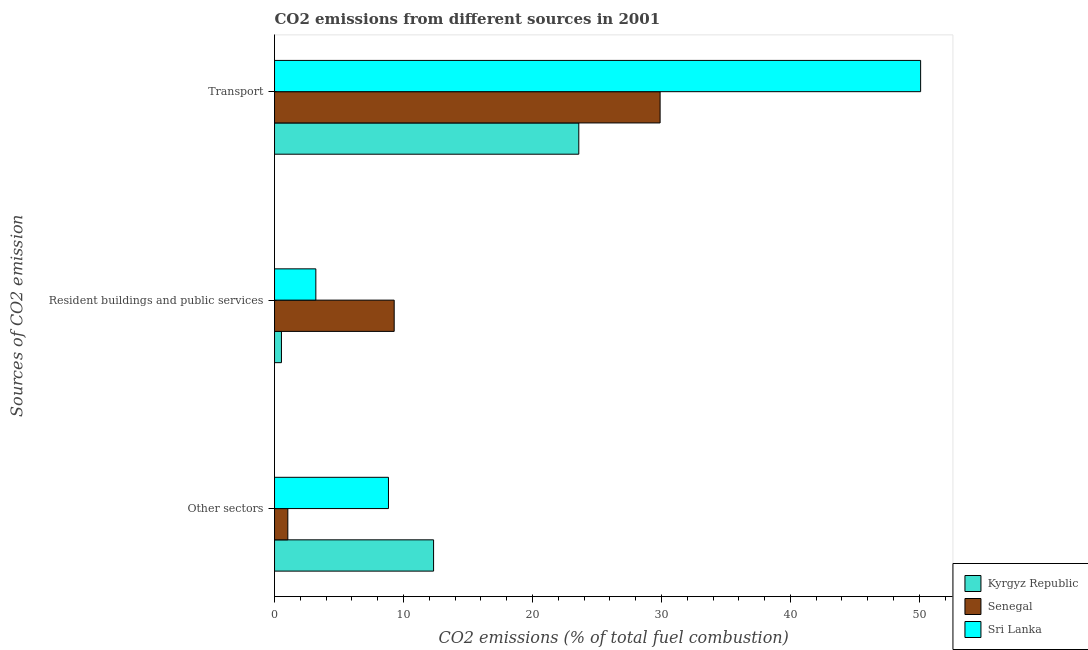How many different coloured bars are there?
Give a very brief answer. 3. Are the number of bars per tick equal to the number of legend labels?
Your answer should be compact. Yes. How many bars are there on the 3rd tick from the top?
Give a very brief answer. 3. How many bars are there on the 3rd tick from the bottom?
Keep it short and to the point. 3. What is the label of the 2nd group of bars from the top?
Give a very brief answer. Resident buildings and public services. What is the percentage of co2 emissions from transport in Kyrgyz Republic?
Offer a terse response. 23.59. Across all countries, what is the maximum percentage of co2 emissions from other sectors?
Your answer should be compact. 12.33. Across all countries, what is the minimum percentage of co2 emissions from other sectors?
Provide a succinct answer. 1.03. In which country was the percentage of co2 emissions from transport maximum?
Your response must be concise. Sri Lanka. In which country was the percentage of co2 emissions from transport minimum?
Provide a short and direct response. Kyrgyz Republic. What is the total percentage of co2 emissions from resident buildings and public services in the graph?
Offer a terse response. 13.02. What is the difference between the percentage of co2 emissions from transport in Sri Lanka and that in Senegal?
Give a very brief answer. 20.2. What is the difference between the percentage of co2 emissions from other sectors in Senegal and the percentage of co2 emissions from resident buildings and public services in Kyrgyz Republic?
Your answer should be compact. 0.49. What is the average percentage of co2 emissions from other sectors per country?
Your response must be concise. 7.4. What is the difference between the percentage of co2 emissions from other sectors and percentage of co2 emissions from resident buildings and public services in Senegal?
Offer a terse response. -8.25. In how many countries, is the percentage of co2 emissions from other sectors greater than 2 %?
Give a very brief answer. 2. What is the ratio of the percentage of co2 emissions from transport in Sri Lanka to that in Senegal?
Offer a very short reply. 1.68. Is the difference between the percentage of co2 emissions from transport in Kyrgyz Republic and Senegal greater than the difference between the percentage of co2 emissions from other sectors in Kyrgyz Republic and Senegal?
Your response must be concise. No. What is the difference between the highest and the second highest percentage of co2 emissions from transport?
Your answer should be very brief. 20.2. What is the difference between the highest and the lowest percentage of co2 emissions from resident buildings and public services?
Provide a short and direct response. 8.74. In how many countries, is the percentage of co2 emissions from transport greater than the average percentage of co2 emissions from transport taken over all countries?
Keep it short and to the point. 1. Is the sum of the percentage of co2 emissions from resident buildings and public services in Kyrgyz Republic and Sri Lanka greater than the maximum percentage of co2 emissions from other sectors across all countries?
Keep it short and to the point. No. What does the 1st bar from the top in Resident buildings and public services represents?
Ensure brevity in your answer.  Sri Lanka. What does the 3rd bar from the bottom in Other sectors represents?
Your answer should be compact. Sri Lanka. How many bars are there?
Offer a terse response. 9. How many countries are there in the graph?
Your response must be concise. 3. What is the difference between two consecutive major ticks on the X-axis?
Offer a very short reply. 10. Are the values on the major ticks of X-axis written in scientific E-notation?
Offer a terse response. No. Where does the legend appear in the graph?
Your response must be concise. Bottom right. How many legend labels are there?
Your response must be concise. 3. What is the title of the graph?
Ensure brevity in your answer.  CO2 emissions from different sources in 2001. What is the label or title of the X-axis?
Provide a short and direct response. CO2 emissions (% of total fuel combustion). What is the label or title of the Y-axis?
Provide a succinct answer. Sources of CO2 emission. What is the CO2 emissions (% of total fuel combustion) in Kyrgyz Republic in Other sectors?
Your response must be concise. 12.33. What is the CO2 emissions (% of total fuel combustion) of Senegal in Other sectors?
Offer a terse response. 1.03. What is the CO2 emissions (% of total fuel combustion) in Sri Lanka in Other sectors?
Your answer should be very brief. 8.83. What is the CO2 emissions (% of total fuel combustion) in Kyrgyz Republic in Resident buildings and public services?
Your answer should be very brief. 0.54. What is the CO2 emissions (% of total fuel combustion) of Senegal in Resident buildings and public services?
Your response must be concise. 9.28. What is the CO2 emissions (% of total fuel combustion) in Sri Lanka in Resident buildings and public services?
Give a very brief answer. 3.2. What is the CO2 emissions (% of total fuel combustion) in Kyrgyz Republic in Transport?
Provide a succinct answer. 23.59. What is the CO2 emissions (% of total fuel combustion) in Senegal in Transport?
Your answer should be compact. 29.9. What is the CO2 emissions (% of total fuel combustion) in Sri Lanka in Transport?
Provide a short and direct response. 50.1. Across all Sources of CO2 emission, what is the maximum CO2 emissions (% of total fuel combustion) in Kyrgyz Republic?
Provide a succinct answer. 23.59. Across all Sources of CO2 emission, what is the maximum CO2 emissions (% of total fuel combustion) in Senegal?
Provide a short and direct response. 29.9. Across all Sources of CO2 emission, what is the maximum CO2 emissions (% of total fuel combustion) in Sri Lanka?
Make the answer very short. 50.1. Across all Sources of CO2 emission, what is the minimum CO2 emissions (% of total fuel combustion) in Kyrgyz Republic?
Ensure brevity in your answer.  0.54. Across all Sources of CO2 emission, what is the minimum CO2 emissions (% of total fuel combustion) of Senegal?
Your answer should be compact. 1.03. Across all Sources of CO2 emission, what is the minimum CO2 emissions (% of total fuel combustion) in Sri Lanka?
Keep it short and to the point. 3.2. What is the total CO2 emissions (% of total fuel combustion) in Kyrgyz Republic in the graph?
Offer a terse response. 36.46. What is the total CO2 emissions (% of total fuel combustion) of Senegal in the graph?
Give a very brief answer. 40.21. What is the total CO2 emissions (% of total fuel combustion) of Sri Lanka in the graph?
Provide a succinct answer. 62.14. What is the difference between the CO2 emissions (% of total fuel combustion) of Kyrgyz Republic in Other sectors and that in Resident buildings and public services?
Offer a very short reply. 11.8. What is the difference between the CO2 emissions (% of total fuel combustion) in Senegal in Other sectors and that in Resident buildings and public services?
Offer a terse response. -8.25. What is the difference between the CO2 emissions (% of total fuel combustion) in Sri Lanka in Other sectors and that in Resident buildings and public services?
Provide a succinct answer. 5.63. What is the difference between the CO2 emissions (% of total fuel combustion) in Kyrgyz Republic in Other sectors and that in Transport?
Your response must be concise. -11.26. What is the difference between the CO2 emissions (% of total fuel combustion) of Senegal in Other sectors and that in Transport?
Your answer should be very brief. -28.87. What is the difference between the CO2 emissions (% of total fuel combustion) in Sri Lanka in Other sectors and that in Transport?
Provide a short and direct response. -41.26. What is the difference between the CO2 emissions (% of total fuel combustion) in Kyrgyz Republic in Resident buildings and public services and that in Transport?
Provide a succinct answer. -23.06. What is the difference between the CO2 emissions (% of total fuel combustion) in Senegal in Resident buildings and public services and that in Transport?
Give a very brief answer. -20.62. What is the difference between the CO2 emissions (% of total fuel combustion) in Sri Lanka in Resident buildings and public services and that in Transport?
Keep it short and to the point. -46.89. What is the difference between the CO2 emissions (% of total fuel combustion) in Kyrgyz Republic in Other sectors and the CO2 emissions (% of total fuel combustion) in Senegal in Resident buildings and public services?
Provide a succinct answer. 3.05. What is the difference between the CO2 emissions (% of total fuel combustion) in Kyrgyz Republic in Other sectors and the CO2 emissions (% of total fuel combustion) in Sri Lanka in Resident buildings and public services?
Ensure brevity in your answer.  9.13. What is the difference between the CO2 emissions (% of total fuel combustion) of Senegal in Other sectors and the CO2 emissions (% of total fuel combustion) of Sri Lanka in Resident buildings and public services?
Provide a succinct answer. -2.17. What is the difference between the CO2 emissions (% of total fuel combustion) in Kyrgyz Republic in Other sectors and the CO2 emissions (% of total fuel combustion) in Senegal in Transport?
Offer a very short reply. -17.56. What is the difference between the CO2 emissions (% of total fuel combustion) of Kyrgyz Republic in Other sectors and the CO2 emissions (% of total fuel combustion) of Sri Lanka in Transport?
Your response must be concise. -37.76. What is the difference between the CO2 emissions (% of total fuel combustion) of Senegal in Other sectors and the CO2 emissions (% of total fuel combustion) of Sri Lanka in Transport?
Your answer should be very brief. -49.07. What is the difference between the CO2 emissions (% of total fuel combustion) in Kyrgyz Republic in Resident buildings and public services and the CO2 emissions (% of total fuel combustion) in Senegal in Transport?
Your answer should be very brief. -29.36. What is the difference between the CO2 emissions (% of total fuel combustion) in Kyrgyz Republic in Resident buildings and public services and the CO2 emissions (% of total fuel combustion) in Sri Lanka in Transport?
Give a very brief answer. -49.56. What is the difference between the CO2 emissions (% of total fuel combustion) in Senegal in Resident buildings and public services and the CO2 emissions (% of total fuel combustion) in Sri Lanka in Transport?
Make the answer very short. -40.82. What is the average CO2 emissions (% of total fuel combustion) in Kyrgyz Republic per Sources of CO2 emission?
Provide a succinct answer. 12.15. What is the average CO2 emissions (% of total fuel combustion) in Senegal per Sources of CO2 emission?
Provide a short and direct response. 13.4. What is the average CO2 emissions (% of total fuel combustion) of Sri Lanka per Sources of CO2 emission?
Keep it short and to the point. 20.71. What is the difference between the CO2 emissions (% of total fuel combustion) in Kyrgyz Republic and CO2 emissions (% of total fuel combustion) in Senegal in Other sectors?
Make the answer very short. 11.3. What is the difference between the CO2 emissions (% of total fuel combustion) of Kyrgyz Republic and CO2 emissions (% of total fuel combustion) of Sri Lanka in Other sectors?
Your answer should be very brief. 3.5. What is the difference between the CO2 emissions (% of total fuel combustion) of Senegal and CO2 emissions (% of total fuel combustion) of Sri Lanka in Other sectors?
Ensure brevity in your answer.  -7.8. What is the difference between the CO2 emissions (% of total fuel combustion) in Kyrgyz Republic and CO2 emissions (% of total fuel combustion) in Senegal in Resident buildings and public services?
Your response must be concise. -8.74. What is the difference between the CO2 emissions (% of total fuel combustion) in Kyrgyz Republic and CO2 emissions (% of total fuel combustion) in Sri Lanka in Resident buildings and public services?
Your answer should be very brief. -2.67. What is the difference between the CO2 emissions (% of total fuel combustion) of Senegal and CO2 emissions (% of total fuel combustion) of Sri Lanka in Resident buildings and public services?
Ensure brevity in your answer.  6.07. What is the difference between the CO2 emissions (% of total fuel combustion) of Kyrgyz Republic and CO2 emissions (% of total fuel combustion) of Senegal in Transport?
Your answer should be compact. -6.3. What is the difference between the CO2 emissions (% of total fuel combustion) of Kyrgyz Republic and CO2 emissions (% of total fuel combustion) of Sri Lanka in Transport?
Keep it short and to the point. -26.5. What is the difference between the CO2 emissions (% of total fuel combustion) in Senegal and CO2 emissions (% of total fuel combustion) in Sri Lanka in Transport?
Your response must be concise. -20.2. What is the ratio of the CO2 emissions (% of total fuel combustion) of Sri Lanka in Other sectors to that in Resident buildings and public services?
Ensure brevity in your answer.  2.76. What is the ratio of the CO2 emissions (% of total fuel combustion) of Kyrgyz Republic in Other sectors to that in Transport?
Your answer should be very brief. 0.52. What is the ratio of the CO2 emissions (% of total fuel combustion) of Senegal in Other sectors to that in Transport?
Provide a succinct answer. 0.03. What is the ratio of the CO2 emissions (% of total fuel combustion) of Sri Lanka in Other sectors to that in Transport?
Provide a succinct answer. 0.18. What is the ratio of the CO2 emissions (% of total fuel combustion) in Kyrgyz Republic in Resident buildings and public services to that in Transport?
Provide a succinct answer. 0.02. What is the ratio of the CO2 emissions (% of total fuel combustion) in Senegal in Resident buildings and public services to that in Transport?
Give a very brief answer. 0.31. What is the ratio of the CO2 emissions (% of total fuel combustion) of Sri Lanka in Resident buildings and public services to that in Transport?
Keep it short and to the point. 0.06. What is the difference between the highest and the second highest CO2 emissions (% of total fuel combustion) of Kyrgyz Republic?
Your response must be concise. 11.26. What is the difference between the highest and the second highest CO2 emissions (% of total fuel combustion) of Senegal?
Offer a terse response. 20.62. What is the difference between the highest and the second highest CO2 emissions (% of total fuel combustion) of Sri Lanka?
Offer a terse response. 41.26. What is the difference between the highest and the lowest CO2 emissions (% of total fuel combustion) in Kyrgyz Republic?
Your answer should be compact. 23.06. What is the difference between the highest and the lowest CO2 emissions (% of total fuel combustion) in Senegal?
Ensure brevity in your answer.  28.87. What is the difference between the highest and the lowest CO2 emissions (% of total fuel combustion) in Sri Lanka?
Your response must be concise. 46.89. 